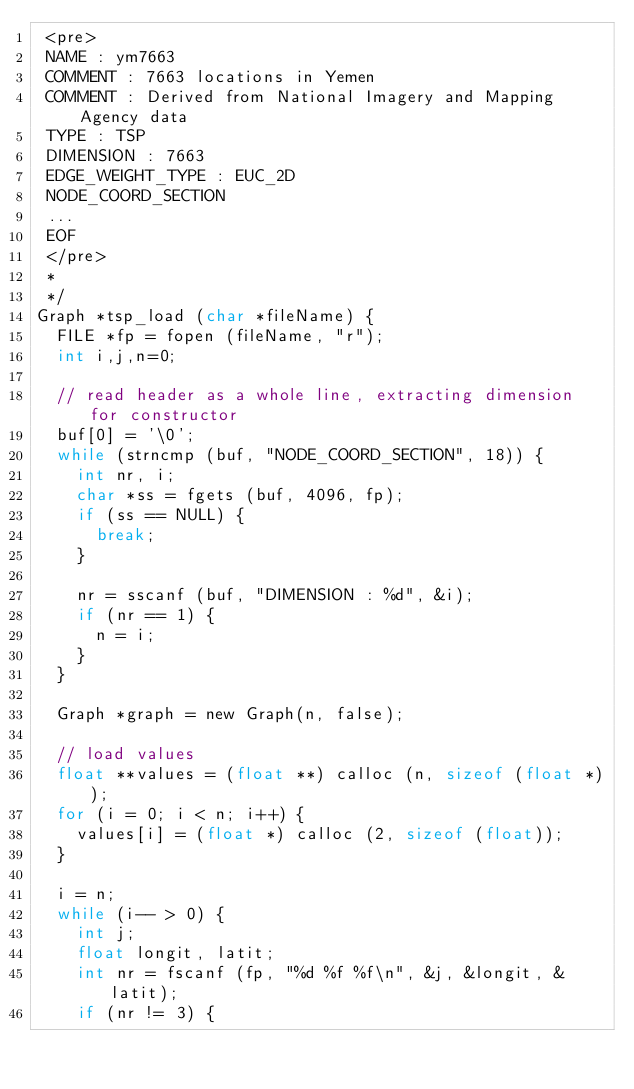Convert code to text. <code><loc_0><loc_0><loc_500><loc_500><_C_> <pre>
 NAME : ym7663
 COMMENT : 7663 locations in Yemen
 COMMENT : Derived from National Imagery and Mapping Agency data
 TYPE : TSP
 DIMENSION : 7663
 EDGE_WEIGHT_TYPE : EUC_2D
 NODE_COORD_SECTION
 ...
 EOF
 </pre>
 *
 */
Graph *tsp_load (char *fileName) {
  FILE *fp = fopen (fileName, "r");
  int i,j,n=0;

  // read header as a whole line, extracting dimension for constructor
  buf[0] = '\0';
  while (strncmp (buf, "NODE_COORD_SECTION", 18)) {
    int nr, i;
    char *ss = fgets (buf, 4096, fp);
    if (ss == NULL) {
      break;
    }

    nr = sscanf (buf, "DIMENSION : %d", &i);
    if (nr == 1) {
      n = i;
    }
  }
  
  Graph *graph = new Graph(n, false);

  // load values
  float **values = (float **) calloc (n, sizeof (float *));
  for (i = 0; i < n; i++) {
    values[i] = (float *) calloc (2, sizeof (float));
  }

  i = n;
  while (i-- > 0) {
    int j; 
    float longit, latit;
    int nr = fscanf (fp, "%d %f %f\n", &j, &longit, &latit);
    if (nr != 3) {</code> 